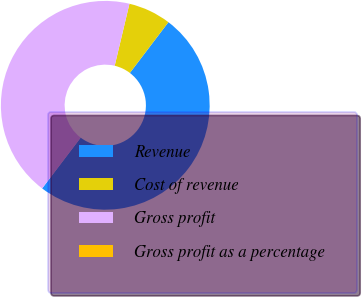<chart> <loc_0><loc_0><loc_500><loc_500><pie_chart><fcel>Revenue<fcel>Cost of revenue<fcel>Gross profit<fcel>Gross profit as a percentage<nl><fcel>50.0%<fcel>6.62%<fcel>43.38%<fcel>0.0%<nl></chart> 